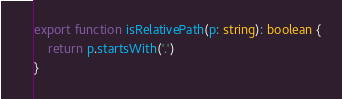<code> <loc_0><loc_0><loc_500><loc_500><_TypeScript_>export function isRelativePath(p: string): boolean {
    return p.startsWith('.')
}
</code> 